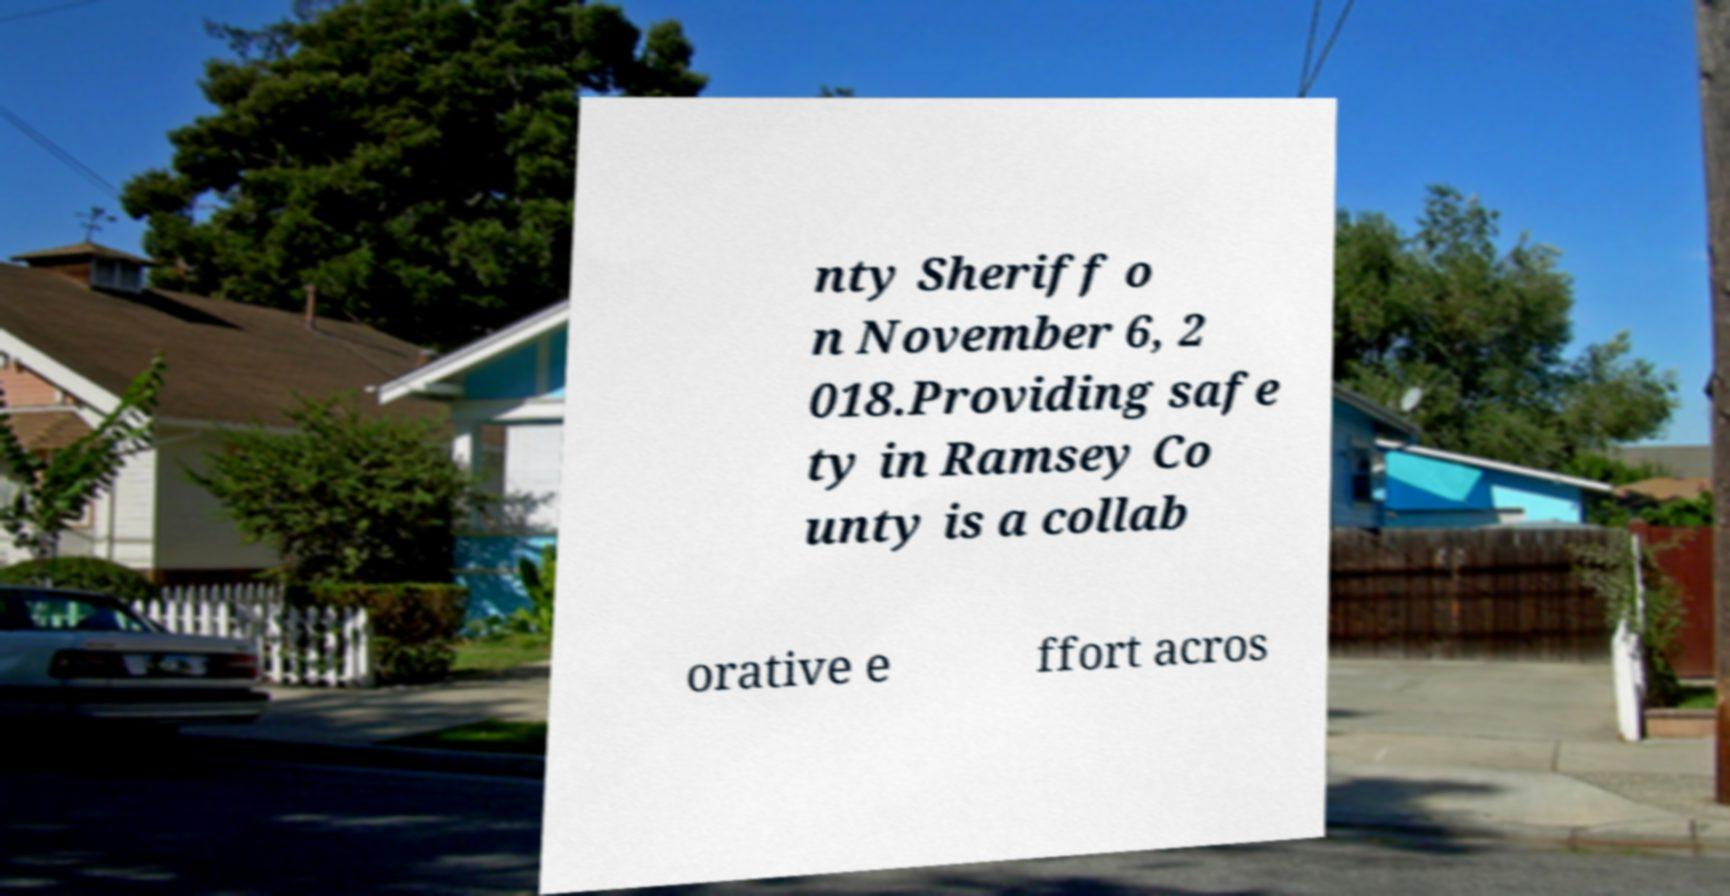I need the written content from this picture converted into text. Can you do that? nty Sheriff o n November 6, 2 018.Providing safe ty in Ramsey Co unty is a collab orative e ffort acros 